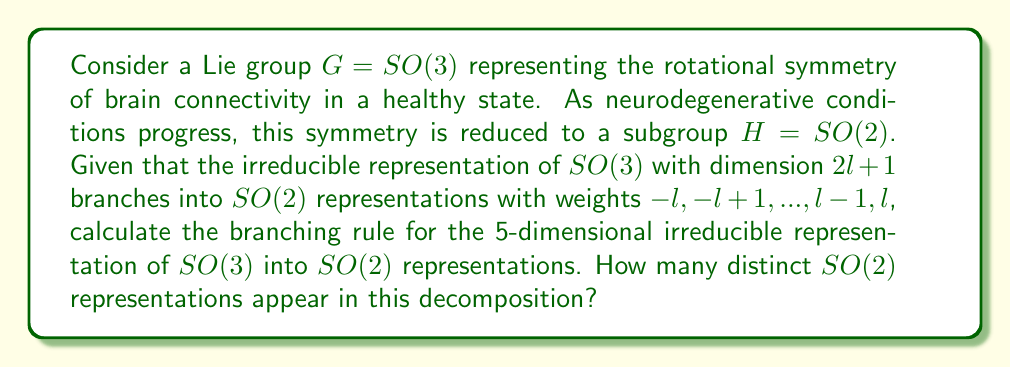Show me your answer to this math problem. Let's approach this step-by-step:

1) The dimension of the given $SO(3)$ representation is 5. We can use the formula $2l+1 = 5$ to find $l$.

2) Solving for $l$:
   $2l + 1 = 5$
   $2l = 4$
   $l = 2$

3) Now that we know $l = 2$, we can determine the weights of the $SO(2)$ representations:
   $-l, -l+1, ..., l-1, l$
   $-2, -1, 0, 1, 2$

4) Each of these weights corresponds to a 1-dimensional representation of $SO(2)$.

5) In the branching rule, the 5-dimensional representation of $SO(3)$ decomposes into the direct sum of these five 1-dimensional representations of $SO(2)$.

6) To count the number of distinct representations, we need to consider that in $SO(2)$, representations with weights $k$ and $-k$ are equivalent for $k \neq 0$.

7) Therefore, we have:
   - One representation for weight 0
   - One representation for weights 1 and -1
   - One representation for weights 2 and -2

Thus, there are 3 distinct $SO(2)$ representations in this decomposition.
Answer: 3 